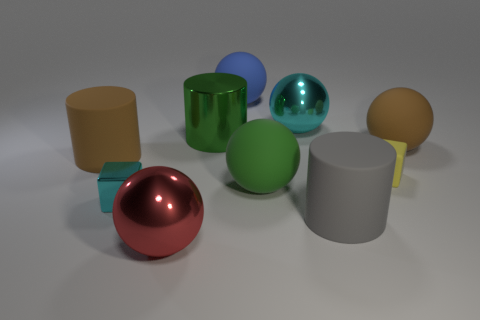What is the material of the thing that is the same color as the metal cylinder?
Provide a succinct answer. Rubber. What size is the matte sphere that is both behind the yellow matte thing and in front of the big blue ball?
Your response must be concise. Large. How many other things are there of the same material as the big brown cylinder?
Your response must be concise. 5. There is a metallic ball that is on the right side of the big red sphere; what size is it?
Your response must be concise. Large. How many small objects are green objects or red objects?
Your answer should be compact. 0. Is there anything else that is the same color as the metal cylinder?
Provide a succinct answer. Yes. Are there any cyan things left of the big gray thing?
Your answer should be very brief. Yes. What is the size of the brown rubber object behind the brown thing that is to the left of the large gray cylinder?
Provide a short and direct response. Large. Are there an equal number of big blue spheres that are in front of the gray cylinder and small blocks in front of the green rubber thing?
Your answer should be compact. No. Is there a rubber ball that is right of the metal sphere behind the red thing?
Your response must be concise. Yes. 